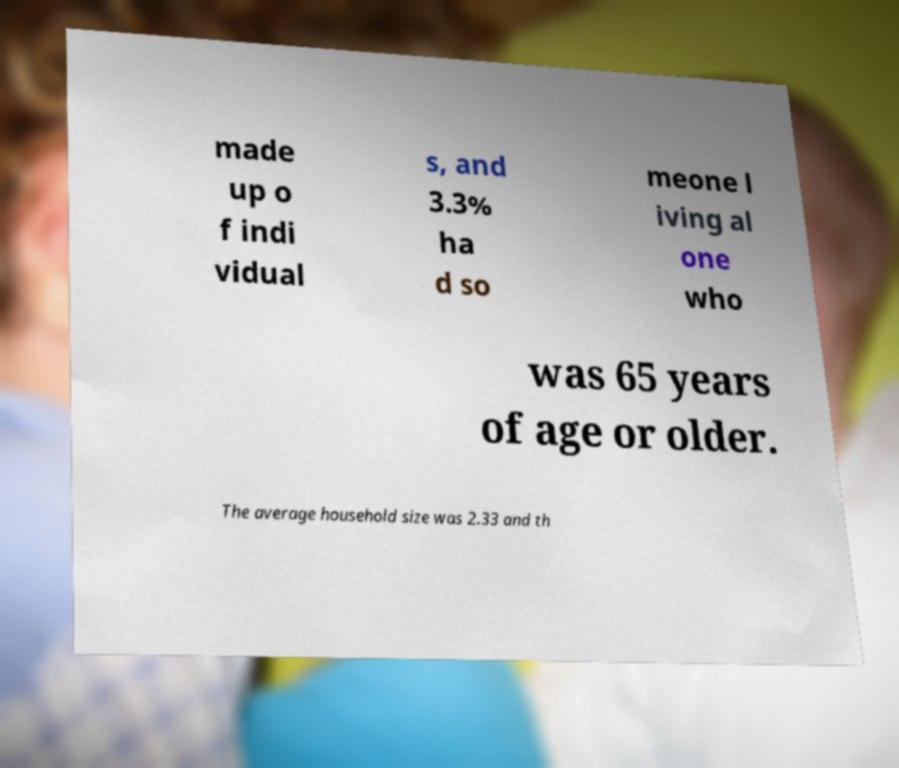Can you read and provide the text displayed in the image?This photo seems to have some interesting text. Can you extract and type it out for me? made up o f indi vidual s, and 3.3% ha d so meone l iving al one who was 65 years of age or older. The average household size was 2.33 and th 